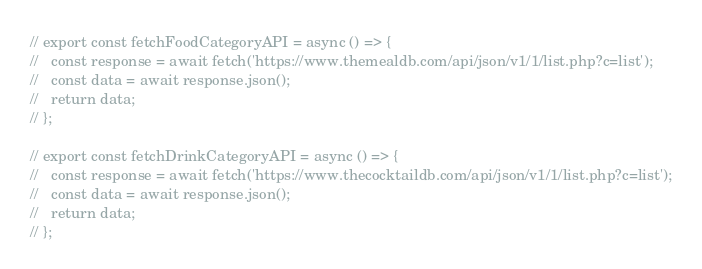<code> <loc_0><loc_0><loc_500><loc_500><_JavaScript_>// export const fetchFoodCategoryAPI = async () => {
//   const response = await fetch('https://www.themealdb.com/api/json/v1/1/list.php?c=list');
//   const data = await response.json();
//   return data;
// };

// export const fetchDrinkCategoryAPI = async () => {
//   const response = await fetch('https://www.thecocktaildb.com/api/json/v1/1/list.php?c=list');
//   const data = await response.json();
//   return data;
// };
</code> 